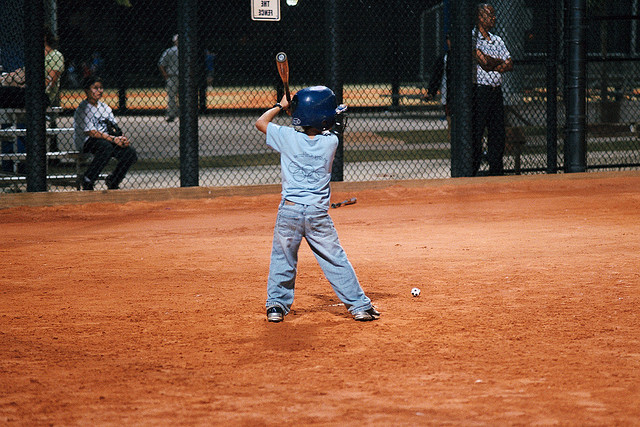<image>Which team is winning? It's uncertain which team is winning. The answer could be the blue team or the home team. Which team is winning? It is unknown which team is winning. 